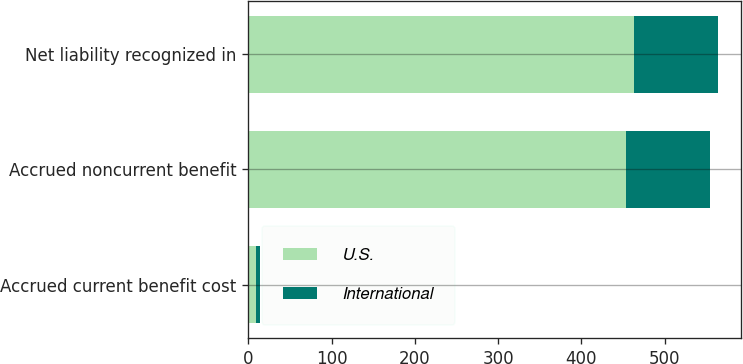Convert chart to OTSL. <chart><loc_0><loc_0><loc_500><loc_500><stacked_bar_chart><ecel><fcel>Accrued current benefit cost<fcel>Accrued noncurrent benefit<fcel>Net liability recognized in<nl><fcel>U.S.<fcel>9.7<fcel>453.7<fcel>463.4<nl><fcel>International<fcel>4.4<fcel>101.1<fcel>100.7<nl></chart> 